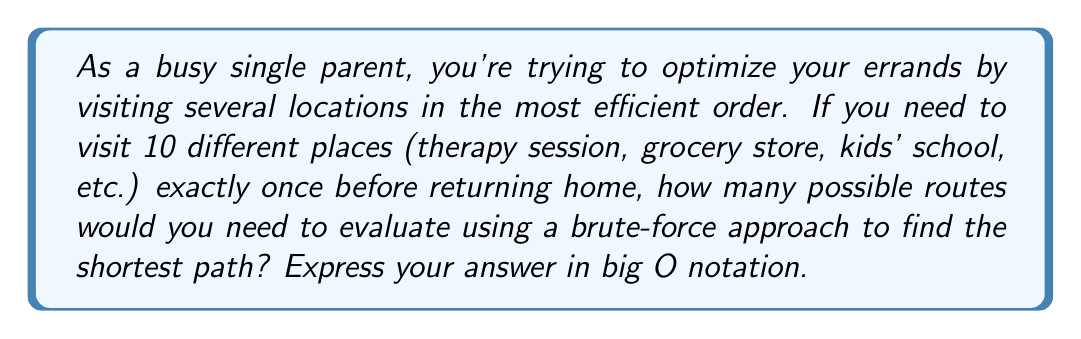Give your solution to this math problem. Let's approach this step-by-step:

1) The Traveling Salesman Problem (TSP) involves finding the shortest possible route that visits each city exactly once and returns to the origin city.

2) For n locations (including the starting point), we have:
   - n choices for the first location
   - (n-1) choices for the second location
   - (n-2) choices for the third location
   - And so on...

3) This gives us n! (n factorial) possible routes.

4) However, in this case, we're starting and ending at home, so we can fix the start point. This reduces our choices to (n-1)! permutations.

5) In big O notation, we typically ignore constant factors. Both n! and (n-1)! are O(n!).

6) The brute-force approach would involve calculating the total distance for each of these (n-1)! routes and comparing them to find the shortest.

7) In this specific problem, n = 10 (9 locations to visit plus home).

8) Therefore, the computational complexity of the brute-force approach for this problem is O(n!) = O(10!).

9) It's worth noting that n! grows extremely quickly. Even for just 10 locations, 10! = 3,628,800 possible routes to evaluate.
Answer: O(n!) or O(10!) 